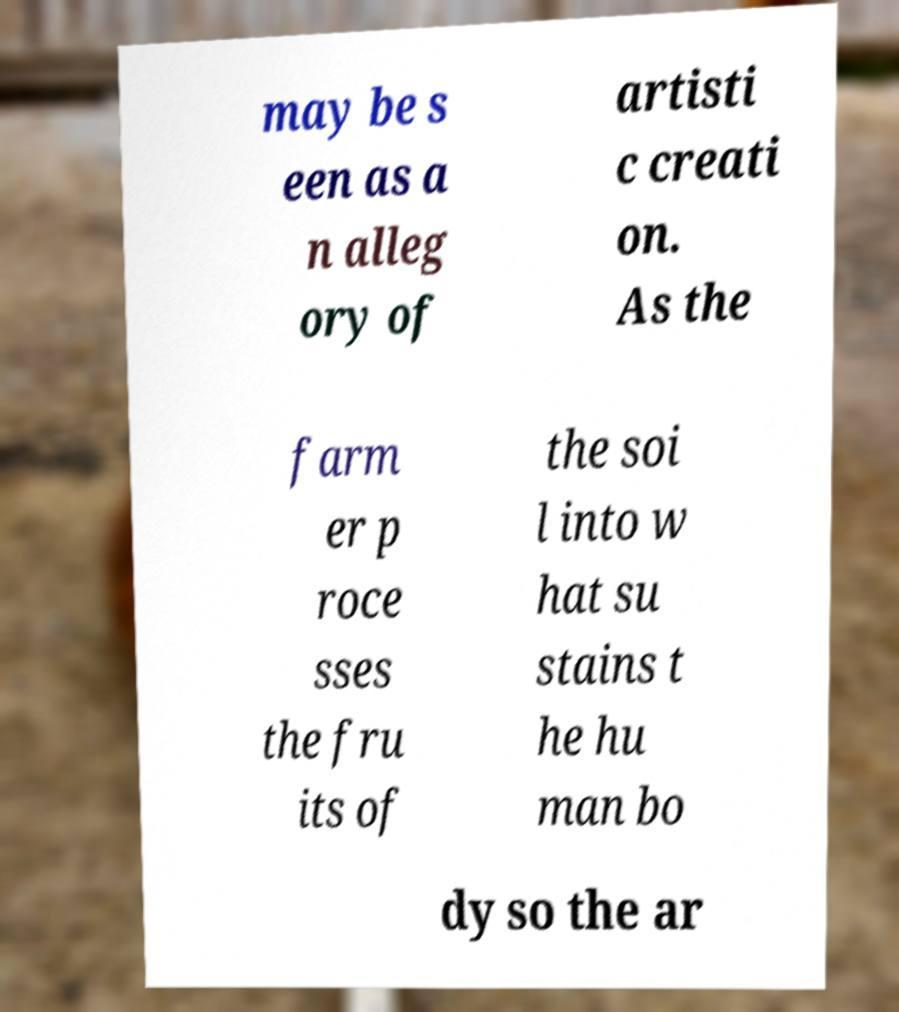Please read and relay the text visible in this image. What does it say? may be s een as a n alleg ory of artisti c creati on. As the farm er p roce sses the fru its of the soi l into w hat su stains t he hu man bo dy so the ar 